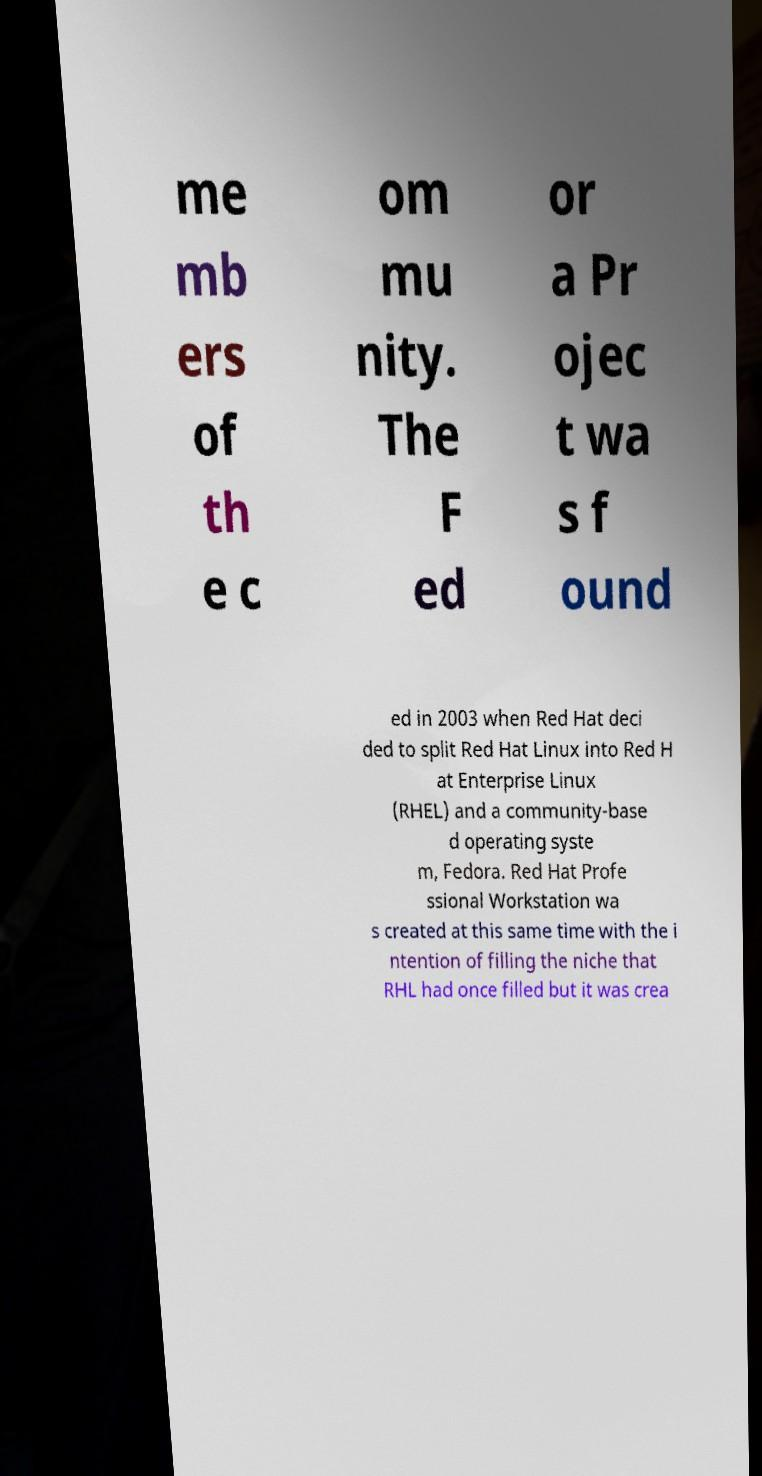Could you assist in decoding the text presented in this image and type it out clearly? me mb ers of th e c om mu nity. The F ed or a Pr ojec t wa s f ound ed in 2003 when Red Hat deci ded to split Red Hat Linux into Red H at Enterprise Linux (RHEL) and a community-base d operating syste m, Fedora. Red Hat Profe ssional Workstation wa s created at this same time with the i ntention of filling the niche that RHL had once filled but it was crea 